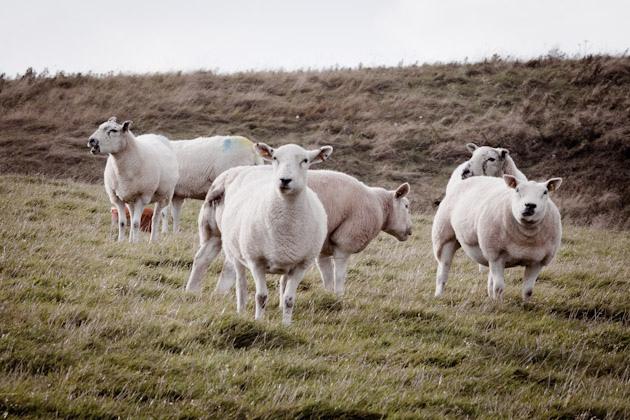Are the sheep shorn?
Answer briefly. Yes. How many sheep are there?
Give a very brief answer. 6. What are the goats standing on?
Be succinct. Grass. Are the sheep eating?
Short answer required. Yes. 